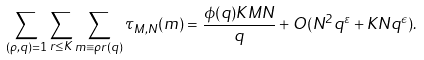<formula> <loc_0><loc_0><loc_500><loc_500>\sum _ { ( \rho , q ) = 1 } \sum _ { r \leq K } \sum _ { m \equiv \rho r ( q ) } \tau _ { M , N } ( m ) = \frac { \phi ( q ) K M N } { q } + O ( N ^ { 2 } q ^ { \varepsilon } + K N q ^ { \epsilon } ) .</formula> 